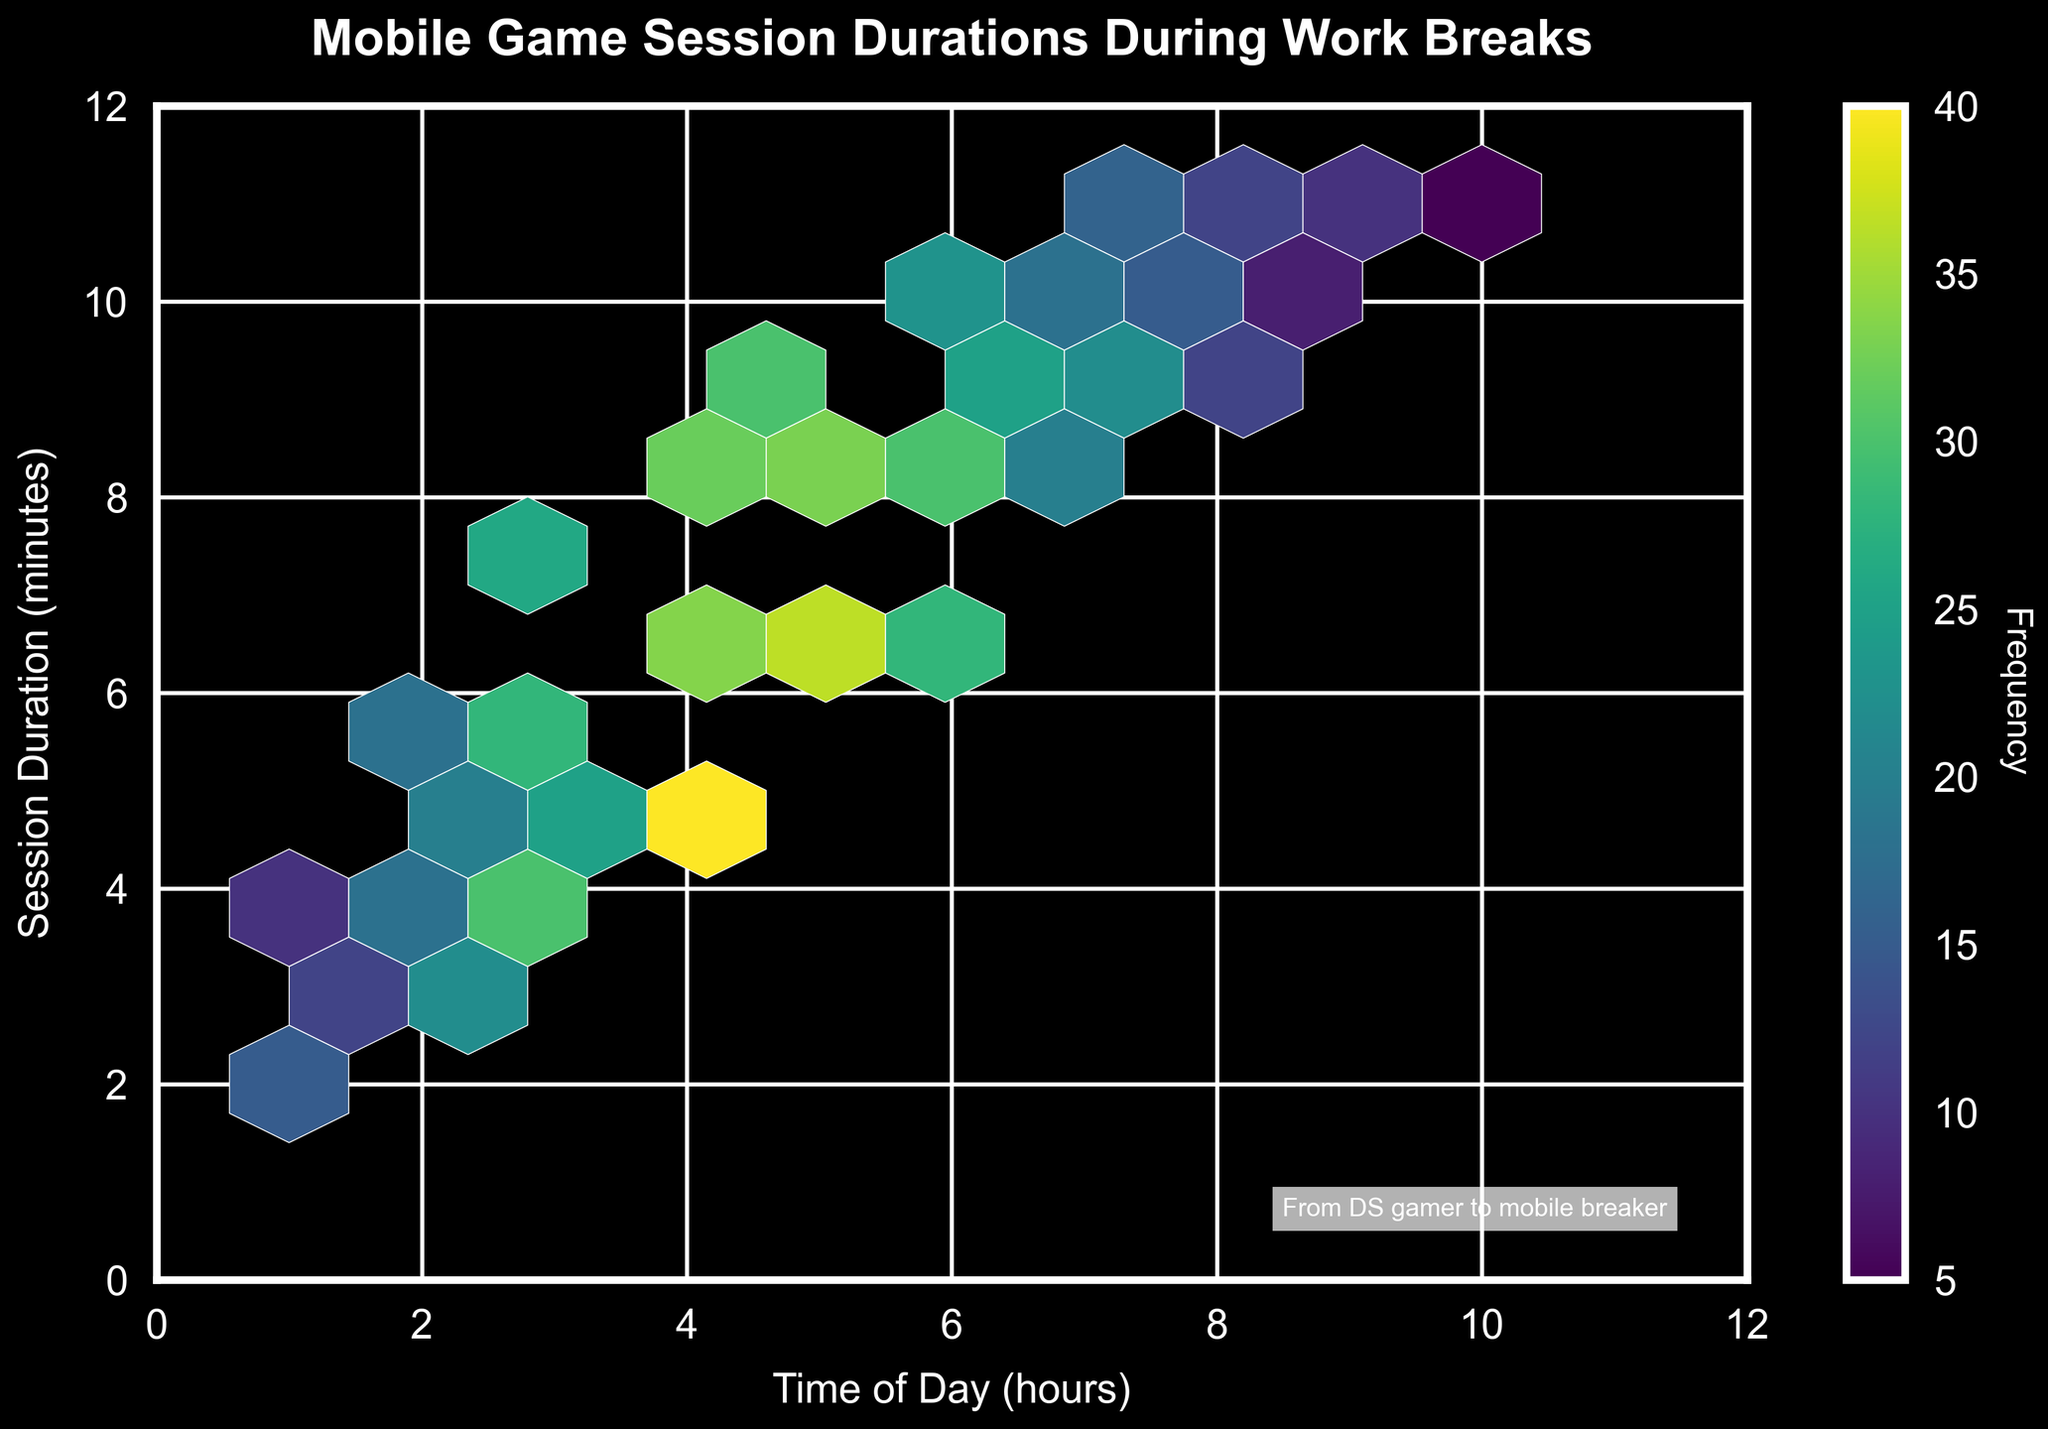What is the title of the Hexbin Plot? The title of a plot is usually positioned at the top and gives an insight into what the plot represents. In this case, the title is "Mobile Game Session Durations During Work Breaks".
Answer: Mobile Game Session Durations During Work Breaks What are the labels on the x and y axes? The labels on the axes provide information about what each axis represents. The x-axis is labeled "Time of Day (hours)" and the y-axis is labeled "Session Duration (minutes)".
Answer: Time of Day (hours), Session Duration (minutes) What is the color of the hexbin plot, and what does it indicate? The color in a hexbin plot represents the frequency of data points within each hexagonal bin. Here, the plot uses a color scale from the 'viridis' colormap. Darker shades represent higher frequencies, while lighter shades represent lower frequencies.
Answer: Different shades of green to yellow indicate frequency, with darker shades representing higher frequencies How is the frequency of hexagons represented in the figure? The frequency of hexagons, which signifies how often specific combinations of x and y values occur, is indicated by both the color of the hexagons and the color bar on the side. The color bar ranges show the frequency values corresponding to the colors.
Answer: By the color and color bar ranging from lower to higher values Where do the highest frequencies of mobile game sessions appear? The highest frequency occurs where the hexagons have the darkest shade. By observing the plot, you can see that the highest frequency appears around the point (5, 7) and (4, 6) on the plot.
Answer: Around (5, 7) and (4, 6) What is the range of session durations shown in the plot? The y-axis of the plot indicates the session duration in minutes. The range shown on the plot runs from 0 to 12 minutes, as marked on the y-axis.
Answer: 0 to 12 minutes What effect does the colormap's gradient from green to yellow have on visual analysis? The gradient effectively highlights variations in frequency, making it easier to distinguish areas of high activity (darker greens) from areas of low activity (lighter greens to yellows). This visually guides the viewer to focus on regions of interest.
Answer: Highlights frequency variations, indicating areas of high and low activity Which time of day seems to have the most frequent game sessions during work breaks? By interpreting the x-axis and color intensity, it is clear that the most frequent game sessions occur around 4 to 6 hours into the workday, as those hexagons have the darkest shades.
Answer: Around 4 to 6 hours Which region in the hexbin plot has the least activity in terms of frequency? The regions with the least activity can be identified by the lightest colors. These regions are around the points (10, 11) on the x-axis and (5, 11) on the y-axis, indicating minimal game sessions at these times and durations.
Answer: Around (10, 11) on the x-axis and (5, 11) on the y-axis Is there a noticeable trend or pattern in the data distribution? The data shows an increasing and then decreasing trend of frequency, peaking around the middle values of both axes. This suggests that during midday work breaks, people tend to play games more frequently, with longer sessions towards the middle of the day as opposed to the beginning or end.
Answer: Increasing and then decreasing trend, peaking around midday 